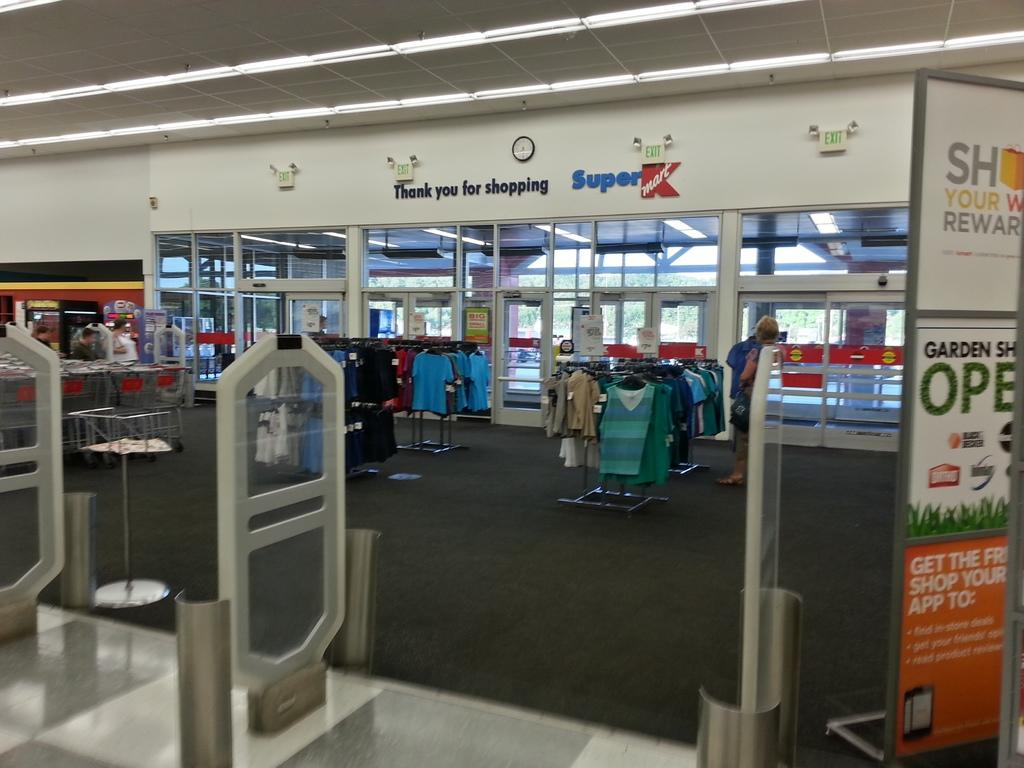<image>
Create a compact narrative representing the image presented. At the entrance of this Super K store are a number of shirts available for purchase. 